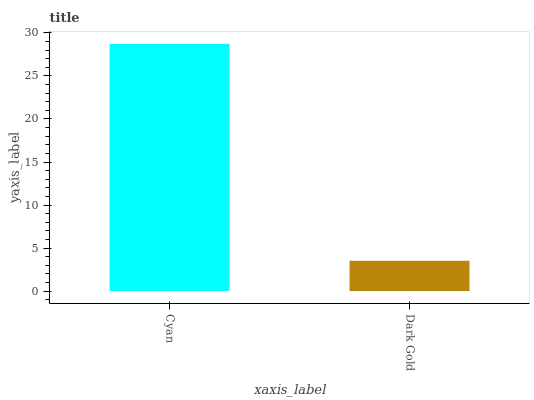Is Dark Gold the minimum?
Answer yes or no. Yes. Is Cyan the maximum?
Answer yes or no. Yes. Is Dark Gold the maximum?
Answer yes or no. No. Is Cyan greater than Dark Gold?
Answer yes or no. Yes. Is Dark Gold less than Cyan?
Answer yes or no. Yes. Is Dark Gold greater than Cyan?
Answer yes or no. No. Is Cyan less than Dark Gold?
Answer yes or no. No. Is Cyan the high median?
Answer yes or no. Yes. Is Dark Gold the low median?
Answer yes or no. Yes. Is Dark Gold the high median?
Answer yes or no. No. Is Cyan the low median?
Answer yes or no. No. 